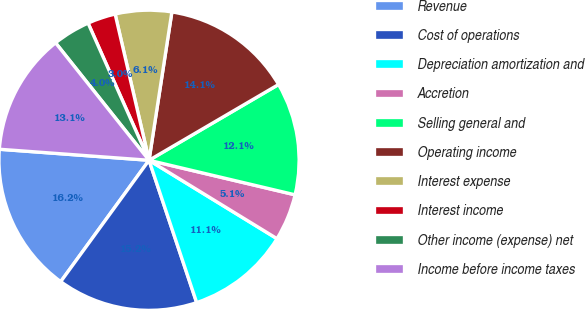Convert chart to OTSL. <chart><loc_0><loc_0><loc_500><loc_500><pie_chart><fcel>Revenue<fcel>Cost of operations<fcel>Depreciation amortization and<fcel>Accretion<fcel>Selling general and<fcel>Operating income<fcel>Interest expense<fcel>Interest income<fcel>Other income (expense) net<fcel>Income before income taxes<nl><fcel>16.16%<fcel>15.15%<fcel>11.11%<fcel>5.05%<fcel>12.12%<fcel>14.14%<fcel>6.06%<fcel>3.03%<fcel>4.04%<fcel>13.13%<nl></chart> 